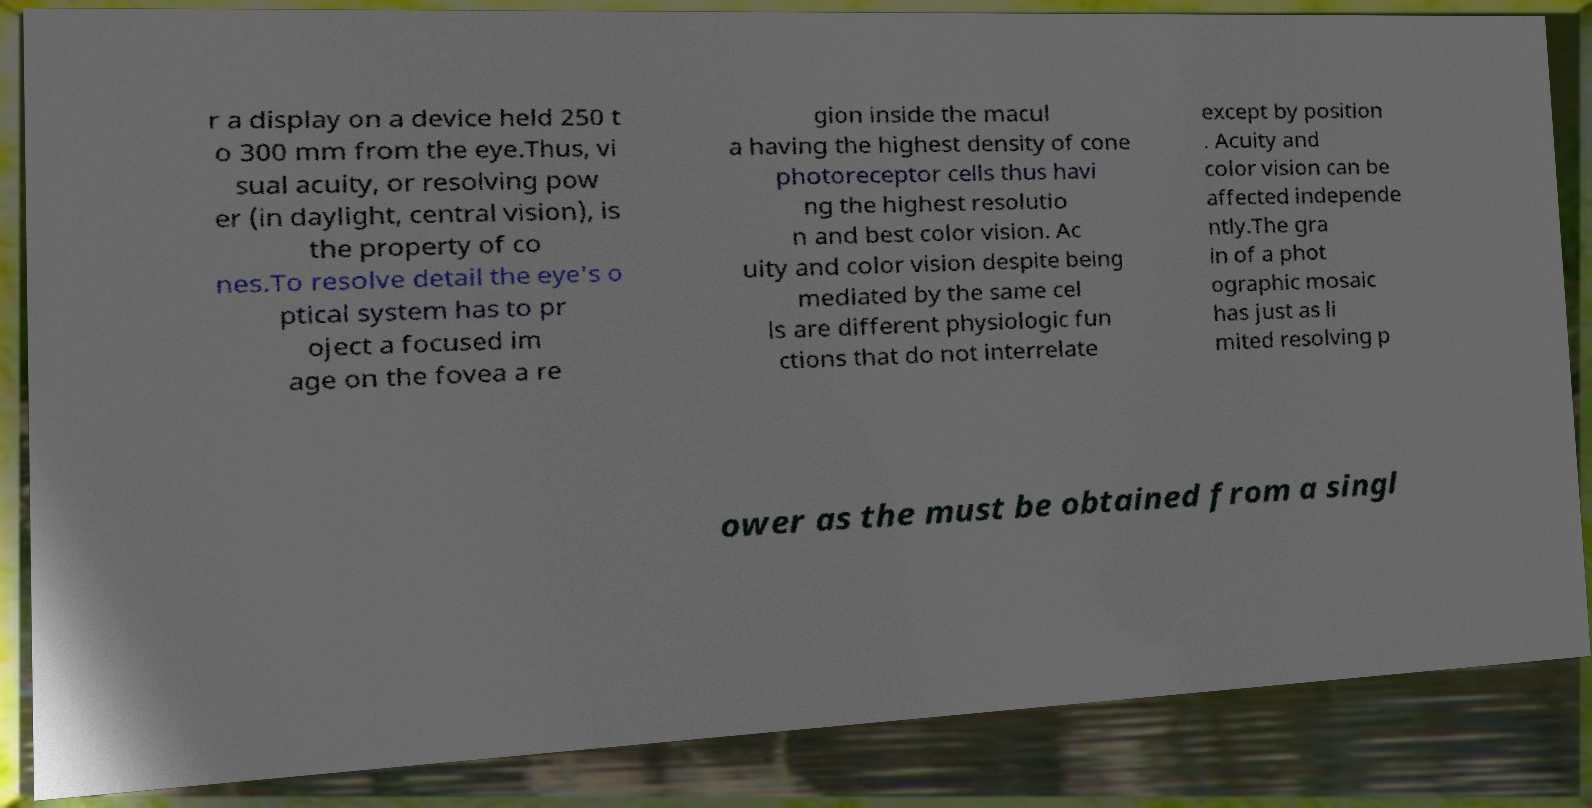Please read and relay the text visible in this image. What does it say? r a display on a device held 250 t o 300 mm from the eye.Thus, vi sual acuity, or resolving pow er (in daylight, central vision), is the property of co nes.To resolve detail the eye's o ptical system has to pr oject a focused im age on the fovea a re gion inside the macul a having the highest density of cone photoreceptor cells thus havi ng the highest resolutio n and best color vision. Ac uity and color vision despite being mediated by the same cel ls are different physiologic fun ctions that do not interrelate except by position . Acuity and color vision can be affected independe ntly.The gra in of a phot ographic mosaic has just as li mited resolving p ower as the must be obtained from a singl 